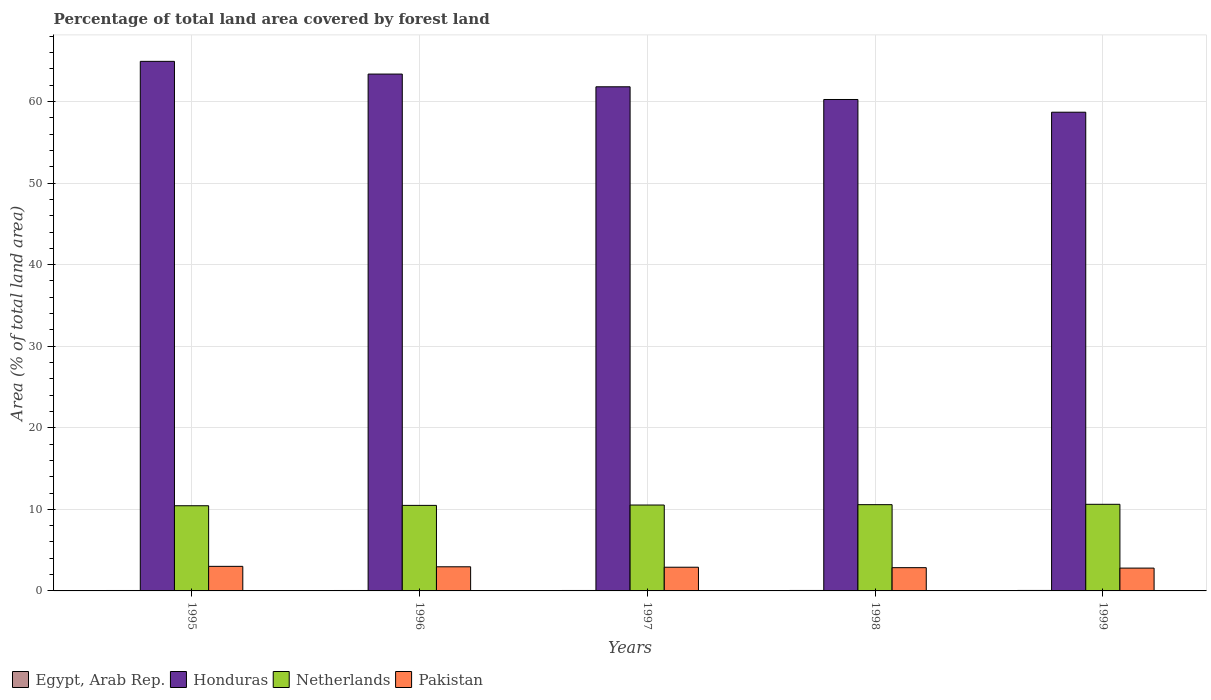How many groups of bars are there?
Offer a very short reply. 5. How many bars are there on the 4th tick from the right?
Give a very brief answer. 4. What is the percentage of forest land in Pakistan in 1997?
Give a very brief answer. 2.9. Across all years, what is the maximum percentage of forest land in Netherlands?
Offer a very short reply. 10.62. Across all years, what is the minimum percentage of forest land in Netherlands?
Make the answer very short. 10.44. What is the total percentage of forest land in Pakistan in the graph?
Ensure brevity in your answer.  14.52. What is the difference between the percentage of forest land in Pakistan in 1997 and that in 1999?
Keep it short and to the point. 0.11. What is the difference between the percentage of forest land in Pakistan in 1997 and the percentage of forest land in Honduras in 1996?
Give a very brief answer. -60.46. What is the average percentage of forest land in Egypt, Arab Rep. per year?
Keep it short and to the point. 0.05. In the year 1995, what is the difference between the percentage of forest land in Egypt, Arab Rep. and percentage of forest land in Honduras?
Offer a very short reply. -64.87. What is the ratio of the percentage of forest land in Pakistan in 1997 to that in 1999?
Offer a terse response. 1.04. Is the percentage of forest land in Pakistan in 1996 less than that in 1999?
Your response must be concise. No. Is the difference between the percentage of forest land in Egypt, Arab Rep. in 1998 and 1999 greater than the difference between the percentage of forest land in Honduras in 1998 and 1999?
Keep it short and to the point. No. What is the difference between the highest and the second highest percentage of forest land in Pakistan?
Ensure brevity in your answer.  0.05. What is the difference between the highest and the lowest percentage of forest land in Pakistan?
Your answer should be very brief. 0.21. In how many years, is the percentage of forest land in Egypt, Arab Rep. greater than the average percentage of forest land in Egypt, Arab Rep. taken over all years?
Your answer should be compact. 2. What does the 4th bar from the left in 1999 represents?
Provide a short and direct response. Pakistan. What does the 2nd bar from the right in 1998 represents?
Ensure brevity in your answer.  Netherlands. Is it the case that in every year, the sum of the percentage of forest land in Pakistan and percentage of forest land in Netherlands is greater than the percentage of forest land in Egypt, Arab Rep.?
Offer a very short reply. Yes. How many bars are there?
Offer a very short reply. 20. Are all the bars in the graph horizontal?
Your answer should be compact. No. What is the difference between two consecutive major ticks on the Y-axis?
Give a very brief answer. 10. Are the values on the major ticks of Y-axis written in scientific E-notation?
Your response must be concise. No. Does the graph contain grids?
Make the answer very short. Yes. How many legend labels are there?
Give a very brief answer. 4. How are the legend labels stacked?
Offer a very short reply. Horizontal. What is the title of the graph?
Keep it short and to the point. Percentage of total land area covered by forest land. Does "Burundi" appear as one of the legend labels in the graph?
Ensure brevity in your answer.  No. What is the label or title of the Y-axis?
Keep it short and to the point. Area (% of total land area). What is the Area (% of total land area) of Egypt, Arab Rep. in 1995?
Provide a short and direct response. 0.05. What is the Area (% of total land area) of Honduras in 1995?
Offer a very short reply. 64.92. What is the Area (% of total land area) of Netherlands in 1995?
Your response must be concise. 10.44. What is the Area (% of total land area) in Pakistan in 1995?
Keep it short and to the point. 3.01. What is the Area (% of total land area) in Egypt, Arab Rep. in 1996?
Provide a short and direct response. 0.05. What is the Area (% of total land area) in Honduras in 1996?
Your answer should be compact. 63.36. What is the Area (% of total land area) in Netherlands in 1996?
Your answer should be very brief. 10.49. What is the Area (% of total land area) in Pakistan in 1996?
Offer a very short reply. 2.96. What is the Area (% of total land area) in Egypt, Arab Rep. in 1997?
Ensure brevity in your answer.  0.05. What is the Area (% of total land area) of Honduras in 1997?
Ensure brevity in your answer.  61.8. What is the Area (% of total land area) of Netherlands in 1997?
Your response must be concise. 10.53. What is the Area (% of total land area) of Pakistan in 1997?
Offer a very short reply. 2.9. What is the Area (% of total land area) in Egypt, Arab Rep. in 1998?
Offer a terse response. 0.06. What is the Area (% of total land area) in Honduras in 1998?
Offer a terse response. 60.24. What is the Area (% of total land area) of Netherlands in 1998?
Your answer should be compact. 10.57. What is the Area (% of total land area) of Pakistan in 1998?
Your response must be concise. 2.85. What is the Area (% of total land area) of Egypt, Arab Rep. in 1999?
Ensure brevity in your answer.  0.06. What is the Area (% of total land area) in Honduras in 1999?
Provide a short and direct response. 58.69. What is the Area (% of total land area) in Netherlands in 1999?
Your answer should be compact. 10.62. What is the Area (% of total land area) in Pakistan in 1999?
Offer a very short reply. 2.8. Across all years, what is the maximum Area (% of total land area) of Egypt, Arab Rep.?
Make the answer very short. 0.06. Across all years, what is the maximum Area (% of total land area) in Honduras?
Provide a succinct answer. 64.92. Across all years, what is the maximum Area (% of total land area) in Netherlands?
Provide a succinct answer. 10.62. Across all years, what is the maximum Area (% of total land area) in Pakistan?
Your answer should be very brief. 3.01. Across all years, what is the minimum Area (% of total land area) in Egypt, Arab Rep.?
Make the answer very short. 0.05. Across all years, what is the minimum Area (% of total land area) in Honduras?
Offer a very short reply. 58.69. Across all years, what is the minimum Area (% of total land area) in Netherlands?
Offer a very short reply. 10.44. Across all years, what is the minimum Area (% of total land area) of Pakistan?
Make the answer very short. 2.8. What is the total Area (% of total land area) in Egypt, Arab Rep. in the graph?
Your response must be concise. 0.27. What is the total Area (% of total land area) in Honduras in the graph?
Provide a short and direct response. 309.02. What is the total Area (% of total land area) in Netherlands in the graph?
Your answer should be compact. 52.65. What is the total Area (% of total land area) of Pakistan in the graph?
Keep it short and to the point. 14.52. What is the difference between the Area (% of total land area) in Egypt, Arab Rep. in 1995 and that in 1996?
Offer a very short reply. -0. What is the difference between the Area (% of total land area) of Honduras in 1995 and that in 1996?
Give a very brief answer. 1.56. What is the difference between the Area (% of total land area) in Netherlands in 1995 and that in 1996?
Ensure brevity in your answer.  -0.04. What is the difference between the Area (% of total land area) of Pakistan in 1995 and that in 1996?
Your response must be concise. 0.05. What is the difference between the Area (% of total land area) of Egypt, Arab Rep. in 1995 and that in 1997?
Provide a short and direct response. -0. What is the difference between the Area (% of total land area) of Honduras in 1995 and that in 1997?
Offer a very short reply. 3.12. What is the difference between the Area (% of total land area) of Netherlands in 1995 and that in 1997?
Your answer should be very brief. -0.09. What is the difference between the Area (% of total land area) in Pakistan in 1995 and that in 1997?
Make the answer very short. 0.11. What is the difference between the Area (% of total land area) of Egypt, Arab Rep. in 1995 and that in 1998?
Your answer should be very brief. -0. What is the difference between the Area (% of total land area) of Honduras in 1995 and that in 1998?
Provide a succinct answer. 4.68. What is the difference between the Area (% of total land area) in Netherlands in 1995 and that in 1998?
Your answer should be compact. -0.13. What is the difference between the Area (% of total land area) in Pakistan in 1995 and that in 1998?
Make the answer very short. 0.16. What is the difference between the Area (% of total land area) in Egypt, Arab Rep. in 1995 and that in 1999?
Your answer should be very brief. -0.01. What is the difference between the Area (% of total land area) in Honduras in 1995 and that in 1999?
Your response must be concise. 6.23. What is the difference between the Area (% of total land area) of Netherlands in 1995 and that in 1999?
Your answer should be very brief. -0.18. What is the difference between the Area (% of total land area) of Pakistan in 1995 and that in 1999?
Provide a succinct answer. 0.21. What is the difference between the Area (% of total land area) in Egypt, Arab Rep. in 1996 and that in 1997?
Give a very brief answer. -0. What is the difference between the Area (% of total land area) of Honduras in 1996 and that in 1997?
Offer a very short reply. 1.56. What is the difference between the Area (% of total land area) in Netherlands in 1996 and that in 1997?
Your answer should be compact. -0.04. What is the difference between the Area (% of total land area) in Pakistan in 1996 and that in 1997?
Your answer should be very brief. 0.05. What is the difference between the Area (% of total land area) of Egypt, Arab Rep. in 1996 and that in 1998?
Make the answer very short. -0. What is the difference between the Area (% of total land area) of Honduras in 1996 and that in 1998?
Ensure brevity in your answer.  3.12. What is the difference between the Area (% of total land area) of Netherlands in 1996 and that in 1998?
Keep it short and to the point. -0.09. What is the difference between the Area (% of total land area) of Pakistan in 1996 and that in 1998?
Make the answer very short. 0.11. What is the difference between the Area (% of total land area) in Egypt, Arab Rep. in 1996 and that in 1999?
Provide a succinct answer. -0. What is the difference between the Area (% of total land area) of Honduras in 1996 and that in 1999?
Make the answer very short. 4.68. What is the difference between the Area (% of total land area) in Netherlands in 1996 and that in 1999?
Ensure brevity in your answer.  -0.13. What is the difference between the Area (% of total land area) in Pakistan in 1996 and that in 1999?
Provide a succinct answer. 0.16. What is the difference between the Area (% of total land area) of Egypt, Arab Rep. in 1997 and that in 1998?
Your answer should be compact. -0. What is the difference between the Area (% of total land area) in Honduras in 1997 and that in 1998?
Keep it short and to the point. 1.56. What is the difference between the Area (% of total land area) of Netherlands in 1997 and that in 1998?
Ensure brevity in your answer.  -0.04. What is the difference between the Area (% of total land area) in Pakistan in 1997 and that in 1998?
Make the answer very short. 0.05. What is the difference between the Area (% of total land area) of Egypt, Arab Rep. in 1997 and that in 1999?
Provide a succinct answer. -0. What is the difference between the Area (% of total land area) of Honduras in 1997 and that in 1999?
Your answer should be very brief. 3.12. What is the difference between the Area (% of total land area) of Netherlands in 1997 and that in 1999?
Your answer should be compact. -0.09. What is the difference between the Area (% of total land area) in Pakistan in 1997 and that in 1999?
Give a very brief answer. 0.11. What is the difference between the Area (% of total land area) of Egypt, Arab Rep. in 1998 and that in 1999?
Give a very brief answer. -0. What is the difference between the Area (% of total land area) of Honduras in 1998 and that in 1999?
Your response must be concise. 1.56. What is the difference between the Area (% of total land area) of Netherlands in 1998 and that in 1999?
Keep it short and to the point. -0.04. What is the difference between the Area (% of total land area) of Pakistan in 1998 and that in 1999?
Offer a terse response. 0.05. What is the difference between the Area (% of total land area) in Egypt, Arab Rep. in 1995 and the Area (% of total land area) in Honduras in 1996?
Provide a succinct answer. -63.31. What is the difference between the Area (% of total land area) in Egypt, Arab Rep. in 1995 and the Area (% of total land area) in Netherlands in 1996?
Provide a succinct answer. -10.43. What is the difference between the Area (% of total land area) of Egypt, Arab Rep. in 1995 and the Area (% of total land area) of Pakistan in 1996?
Your answer should be compact. -2.91. What is the difference between the Area (% of total land area) in Honduras in 1995 and the Area (% of total land area) in Netherlands in 1996?
Your answer should be compact. 54.44. What is the difference between the Area (% of total land area) of Honduras in 1995 and the Area (% of total land area) of Pakistan in 1996?
Offer a terse response. 61.96. What is the difference between the Area (% of total land area) in Netherlands in 1995 and the Area (% of total land area) in Pakistan in 1996?
Your response must be concise. 7.48. What is the difference between the Area (% of total land area) of Egypt, Arab Rep. in 1995 and the Area (% of total land area) of Honduras in 1997?
Keep it short and to the point. -61.75. What is the difference between the Area (% of total land area) in Egypt, Arab Rep. in 1995 and the Area (% of total land area) in Netherlands in 1997?
Keep it short and to the point. -10.48. What is the difference between the Area (% of total land area) of Egypt, Arab Rep. in 1995 and the Area (% of total land area) of Pakistan in 1997?
Provide a short and direct response. -2.85. What is the difference between the Area (% of total land area) of Honduras in 1995 and the Area (% of total land area) of Netherlands in 1997?
Offer a very short reply. 54.39. What is the difference between the Area (% of total land area) of Honduras in 1995 and the Area (% of total land area) of Pakistan in 1997?
Your answer should be very brief. 62.02. What is the difference between the Area (% of total land area) of Netherlands in 1995 and the Area (% of total land area) of Pakistan in 1997?
Your answer should be very brief. 7.54. What is the difference between the Area (% of total land area) in Egypt, Arab Rep. in 1995 and the Area (% of total land area) in Honduras in 1998?
Ensure brevity in your answer.  -60.19. What is the difference between the Area (% of total land area) of Egypt, Arab Rep. in 1995 and the Area (% of total land area) of Netherlands in 1998?
Provide a short and direct response. -10.52. What is the difference between the Area (% of total land area) in Egypt, Arab Rep. in 1995 and the Area (% of total land area) in Pakistan in 1998?
Keep it short and to the point. -2.8. What is the difference between the Area (% of total land area) of Honduras in 1995 and the Area (% of total land area) of Netherlands in 1998?
Provide a succinct answer. 54.35. What is the difference between the Area (% of total land area) in Honduras in 1995 and the Area (% of total land area) in Pakistan in 1998?
Give a very brief answer. 62.07. What is the difference between the Area (% of total land area) in Netherlands in 1995 and the Area (% of total land area) in Pakistan in 1998?
Provide a succinct answer. 7.59. What is the difference between the Area (% of total land area) of Egypt, Arab Rep. in 1995 and the Area (% of total land area) of Honduras in 1999?
Your answer should be very brief. -58.63. What is the difference between the Area (% of total land area) of Egypt, Arab Rep. in 1995 and the Area (% of total land area) of Netherlands in 1999?
Your answer should be compact. -10.57. What is the difference between the Area (% of total land area) of Egypt, Arab Rep. in 1995 and the Area (% of total land area) of Pakistan in 1999?
Provide a succinct answer. -2.75. What is the difference between the Area (% of total land area) in Honduras in 1995 and the Area (% of total land area) in Netherlands in 1999?
Ensure brevity in your answer.  54.3. What is the difference between the Area (% of total land area) of Honduras in 1995 and the Area (% of total land area) of Pakistan in 1999?
Offer a very short reply. 62.12. What is the difference between the Area (% of total land area) in Netherlands in 1995 and the Area (% of total land area) in Pakistan in 1999?
Your answer should be compact. 7.64. What is the difference between the Area (% of total land area) in Egypt, Arab Rep. in 1996 and the Area (% of total land area) in Honduras in 1997?
Your response must be concise. -61.75. What is the difference between the Area (% of total land area) in Egypt, Arab Rep. in 1996 and the Area (% of total land area) in Netherlands in 1997?
Your answer should be compact. -10.48. What is the difference between the Area (% of total land area) in Egypt, Arab Rep. in 1996 and the Area (% of total land area) in Pakistan in 1997?
Your answer should be very brief. -2.85. What is the difference between the Area (% of total land area) of Honduras in 1996 and the Area (% of total land area) of Netherlands in 1997?
Your answer should be compact. 52.83. What is the difference between the Area (% of total land area) of Honduras in 1996 and the Area (% of total land area) of Pakistan in 1997?
Your answer should be very brief. 60.46. What is the difference between the Area (% of total land area) in Netherlands in 1996 and the Area (% of total land area) in Pakistan in 1997?
Keep it short and to the point. 7.58. What is the difference between the Area (% of total land area) in Egypt, Arab Rep. in 1996 and the Area (% of total land area) in Honduras in 1998?
Provide a succinct answer. -60.19. What is the difference between the Area (% of total land area) in Egypt, Arab Rep. in 1996 and the Area (% of total land area) in Netherlands in 1998?
Provide a succinct answer. -10.52. What is the difference between the Area (% of total land area) of Egypt, Arab Rep. in 1996 and the Area (% of total land area) of Pakistan in 1998?
Provide a short and direct response. -2.8. What is the difference between the Area (% of total land area) of Honduras in 1996 and the Area (% of total land area) of Netherlands in 1998?
Keep it short and to the point. 52.79. What is the difference between the Area (% of total land area) of Honduras in 1996 and the Area (% of total land area) of Pakistan in 1998?
Ensure brevity in your answer.  60.51. What is the difference between the Area (% of total land area) in Netherlands in 1996 and the Area (% of total land area) in Pakistan in 1998?
Your answer should be compact. 7.63. What is the difference between the Area (% of total land area) of Egypt, Arab Rep. in 1996 and the Area (% of total land area) of Honduras in 1999?
Provide a succinct answer. -58.63. What is the difference between the Area (% of total land area) in Egypt, Arab Rep. in 1996 and the Area (% of total land area) in Netherlands in 1999?
Provide a short and direct response. -10.57. What is the difference between the Area (% of total land area) of Egypt, Arab Rep. in 1996 and the Area (% of total land area) of Pakistan in 1999?
Offer a terse response. -2.75. What is the difference between the Area (% of total land area) in Honduras in 1996 and the Area (% of total land area) in Netherlands in 1999?
Provide a succinct answer. 52.74. What is the difference between the Area (% of total land area) in Honduras in 1996 and the Area (% of total land area) in Pakistan in 1999?
Provide a short and direct response. 60.56. What is the difference between the Area (% of total land area) in Netherlands in 1996 and the Area (% of total land area) in Pakistan in 1999?
Your answer should be compact. 7.69. What is the difference between the Area (% of total land area) in Egypt, Arab Rep. in 1997 and the Area (% of total land area) in Honduras in 1998?
Your response must be concise. -60.19. What is the difference between the Area (% of total land area) in Egypt, Arab Rep. in 1997 and the Area (% of total land area) in Netherlands in 1998?
Offer a very short reply. -10.52. What is the difference between the Area (% of total land area) in Egypt, Arab Rep. in 1997 and the Area (% of total land area) in Pakistan in 1998?
Give a very brief answer. -2.8. What is the difference between the Area (% of total land area) in Honduras in 1997 and the Area (% of total land area) in Netherlands in 1998?
Keep it short and to the point. 51.23. What is the difference between the Area (% of total land area) in Honduras in 1997 and the Area (% of total land area) in Pakistan in 1998?
Offer a very short reply. 58.95. What is the difference between the Area (% of total land area) of Netherlands in 1997 and the Area (% of total land area) of Pakistan in 1998?
Your response must be concise. 7.68. What is the difference between the Area (% of total land area) in Egypt, Arab Rep. in 1997 and the Area (% of total land area) in Honduras in 1999?
Give a very brief answer. -58.63. What is the difference between the Area (% of total land area) of Egypt, Arab Rep. in 1997 and the Area (% of total land area) of Netherlands in 1999?
Ensure brevity in your answer.  -10.56. What is the difference between the Area (% of total land area) of Egypt, Arab Rep. in 1997 and the Area (% of total land area) of Pakistan in 1999?
Ensure brevity in your answer.  -2.74. What is the difference between the Area (% of total land area) in Honduras in 1997 and the Area (% of total land area) in Netherlands in 1999?
Give a very brief answer. 51.18. What is the difference between the Area (% of total land area) in Honduras in 1997 and the Area (% of total land area) in Pakistan in 1999?
Your response must be concise. 59.01. What is the difference between the Area (% of total land area) of Netherlands in 1997 and the Area (% of total land area) of Pakistan in 1999?
Make the answer very short. 7.73. What is the difference between the Area (% of total land area) in Egypt, Arab Rep. in 1998 and the Area (% of total land area) in Honduras in 1999?
Your answer should be very brief. -58.63. What is the difference between the Area (% of total land area) of Egypt, Arab Rep. in 1998 and the Area (% of total land area) of Netherlands in 1999?
Make the answer very short. -10.56. What is the difference between the Area (% of total land area) in Egypt, Arab Rep. in 1998 and the Area (% of total land area) in Pakistan in 1999?
Make the answer very short. -2.74. What is the difference between the Area (% of total land area) of Honduras in 1998 and the Area (% of total land area) of Netherlands in 1999?
Give a very brief answer. 49.63. What is the difference between the Area (% of total land area) of Honduras in 1998 and the Area (% of total land area) of Pakistan in 1999?
Your answer should be compact. 57.45. What is the difference between the Area (% of total land area) of Netherlands in 1998 and the Area (% of total land area) of Pakistan in 1999?
Keep it short and to the point. 7.78. What is the average Area (% of total land area) of Egypt, Arab Rep. per year?
Provide a short and direct response. 0.05. What is the average Area (% of total land area) of Honduras per year?
Keep it short and to the point. 61.8. What is the average Area (% of total land area) in Netherlands per year?
Your response must be concise. 10.53. What is the average Area (% of total land area) in Pakistan per year?
Ensure brevity in your answer.  2.9. In the year 1995, what is the difference between the Area (% of total land area) of Egypt, Arab Rep. and Area (% of total land area) of Honduras?
Ensure brevity in your answer.  -64.87. In the year 1995, what is the difference between the Area (% of total land area) in Egypt, Arab Rep. and Area (% of total land area) in Netherlands?
Provide a succinct answer. -10.39. In the year 1995, what is the difference between the Area (% of total land area) in Egypt, Arab Rep. and Area (% of total land area) in Pakistan?
Keep it short and to the point. -2.96. In the year 1995, what is the difference between the Area (% of total land area) in Honduras and Area (% of total land area) in Netherlands?
Offer a very short reply. 54.48. In the year 1995, what is the difference between the Area (% of total land area) of Honduras and Area (% of total land area) of Pakistan?
Offer a very short reply. 61.91. In the year 1995, what is the difference between the Area (% of total land area) in Netherlands and Area (% of total land area) in Pakistan?
Your answer should be compact. 7.43. In the year 1996, what is the difference between the Area (% of total land area) of Egypt, Arab Rep. and Area (% of total land area) of Honduras?
Provide a short and direct response. -63.31. In the year 1996, what is the difference between the Area (% of total land area) of Egypt, Arab Rep. and Area (% of total land area) of Netherlands?
Your answer should be very brief. -10.43. In the year 1996, what is the difference between the Area (% of total land area) of Egypt, Arab Rep. and Area (% of total land area) of Pakistan?
Offer a very short reply. -2.9. In the year 1996, what is the difference between the Area (% of total land area) in Honduras and Area (% of total land area) in Netherlands?
Provide a short and direct response. 52.88. In the year 1996, what is the difference between the Area (% of total land area) in Honduras and Area (% of total land area) in Pakistan?
Make the answer very short. 60.4. In the year 1996, what is the difference between the Area (% of total land area) of Netherlands and Area (% of total land area) of Pakistan?
Offer a very short reply. 7.53. In the year 1997, what is the difference between the Area (% of total land area) in Egypt, Arab Rep. and Area (% of total land area) in Honduras?
Provide a short and direct response. -61.75. In the year 1997, what is the difference between the Area (% of total land area) in Egypt, Arab Rep. and Area (% of total land area) in Netherlands?
Provide a succinct answer. -10.48. In the year 1997, what is the difference between the Area (% of total land area) in Egypt, Arab Rep. and Area (% of total land area) in Pakistan?
Your response must be concise. -2.85. In the year 1997, what is the difference between the Area (% of total land area) of Honduras and Area (% of total land area) of Netherlands?
Make the answer very short. 51.27. In the year 1997, what is the difference between the Area (% of total land area) in Honduras and Area (% of total land area) in Pakistan?
Ensure brevity in your answer.  58.9. In the year 1997, what is the difference between the Area (% of total land area) of Netherlands and Area (% of total land area) of Pakistan?
Offer a very short reply. 7.63. In the year 1998, what is the difference between the Area (% of total land area) in Egypt, Arab Rep. and Area (% of total land area) in Honduras?
Make the answer very short. -60.19. In the year 1998, what is the difference between the Area (% of total land area) in Egypt, Arab Rep. and Area (% of total land area) in Netherlands?
Your answer should be very brief. -10.52. In the year 1998, what is the difference between the Area (% of total land area) in Egypt, Arab Rep. and Area (% of total land area) in Pakistan?
Offer a very short reply. -2.8. In the year 1998, what is the difference between the Area (% of total land area) of Honduras and Area (% of total land area) of Netherlands?
Provide a succinct answer. 49.67. In the year 1998, what is the difference between the Area (% of total land area) in Honduras and Area (% of total land area) in Pakistan?
Your answer should be compact. 57.39. In the year 1998, what is the difference between the Area (% of total land area) of Netherlands and Area (% of total land area) of Pakistan?
Your answer should be compact. 7.72. In the year 1999, what is the difference between the Area (% of total land area) in Egypt, Arab Rep. and Area (% of total land area) in Honduras?
Ensure brevity in your answer.  -58.63. In the year 1999, what is the difference between the Area (% of total land area) in Egypt, Arab Rep. and Area (% of total land area) in Netherlands?
Ensure brevity in your answer.  -10.56. In the year 1999, what is the difference between the Area (% of total land area) in Egypt, Arab Rep. and Area (% of total land area) in Pakistan?
Offer a terse response. -2.74. In the year 1999, what is the difference between the Area (% of total land area) in Honduras and Area (% of total land area) in Netherlands?
Offer a terse response. 48.07. In the year 1999, what is the difference between the Area (% of total land area) in Honduras and Area (% of total land area) in Pakistan?
Provide a succinct answer. 55.89. In the year 1999, what is the difference between the Area (% of total land area) in Netherlands and Area (% of total land area) in Pakistan?
Offer a terse response. 7.82. What is the ratio of the Area (% of total land area) in Egypt, Arab Rep. in 1995 to that in 1996?
Provide a succinct answer. 0.97. What is the ratio of the Area (% of total land area) in Honduras in 1995 to that in 1996?
Provide a short and direct response. 1.02. What is the ratio of the Area (% of total land area) in Pakistan in 1995 to that in 1996?
Offer a very short reply. 1.02. What is the ratio of the Area (% of total land area) of Egypt, Arab Rep. in 1995 to that in 1997?
Provide a short and direct response. 0.94. What is the ratio of the Area (% of total land area) in Honduras in 1995 to that in 1997?
Ensure brevity in your answer.  1.05. What is the ratio of the Area (% of total land area) in Netherlands in 1995 to that in 1997?
Offer a very short reply. 0.99. What is the ratio of the Area (% of total land area) in Pakistan in 1995 to that in 1997?
Offer a terse response. 1.04. What is the ratio of the Area (% of total land area) of Egypt, Arab Rep. in 1995 to that in 1998?
Offer a terse response. 0.92. What is the ratio of the Area (% of total land area) of Honduras in 1995 to that in 1998?
Offer a terse response. 1.08. What is the ratio of the Area (% of total land area) in Netherlands in 1995 to that in 1998?
Offer a terse response. 0.99. What is the ratio of the Area (% of total land area) in Pakistan in 1995 to that in 1998?
Give a very brief answer. 1.06. What is the ratio of the Area (% of total land area) of Egypt, Arab Rep. in 1995 to that in 1999?
Keep it short and to the point. 0.9. What is the ratio of the Area (% of total land area) in Honduras in 1995 to that in 1999?
Provide a short and direct response. 1.11. What is the ratio of the Area (% of total land area) in Netherlands in 1995 to that in 1999?
Give a very brief answer. 0.98. What is the ratio of the Area (% of total land area) in Pakistan in 1995 to that in 1999?
Keep it short and to the point. 1.08. What is the ratio of the Area (% of total land area) in Egypt, Arab Rep. in 1996 to that in 1997?
Keep it short and to the point. 0.97. What is the ratio of the Area (% of total land area) of Honduras in 1996 to that in 1997?
Make the answer very short. 1.03. What is the ratio of the Area (% of total land area) in Pakistan in 1996 to that in 1997?
Your answer should be compact. 1.02. What is the ratio of the Area (% of total land area) of Egypt, Arab Rep. in 1996 to that in 1998?
Provide a short and direct response. 0.95. What is the ratio of the Area (% of total land area) of Honduras in 1996 to that in 1998?
Provide a short and direct response. 1.05. What is the ratio of the Area (% of total land area) in Netherlands in 1996 to that in 1998?
Your answer should be very brief. 0.99. What is the ratio of the Area (% of total land area) in Pakistan in 1996 to that in 1998?
Ensure brevity in your answer.  1.04. What is the ratio of the Area (% of total land area) in Egypt, Arab Rep. in 1996 to that in 1999?
Provide a succinct answer. 0.92. What is the ratio of the Area (% of total land area) of Honduras in 1996 to that in 1999?
Offer a very short reply. 1.08. What is the ratio of the Area (% of total land area) in Netherlands in 1996 to that in 1999?
Provide a succinct answer. 0.99. What is the ratio of the Area (% of total land area) in Pakistan in 1996 to that in 1999?
Ensure brevity in your answer.  1.06. What is the ratio of the Area (% of total land area) of Egypt, Arab Rep. in 1997 to that in 1998?
Ensure brevity in your answer.  0.97. What is the ratio of the Area (% of total land area) of Honduras in 1997 to that in 1998?
Give a very brief answer. 1.03. What is the ratio of the Area (% of total land area) in Netherlands in 1997 to that in 1998?
Offer a terse response. 1. What is the ratio of the Area (% of total land area) of Pakistan in 1997 to that in 1998?
Ensure brevity in your answer.  1.02. What is the ratio of the Area (% of total land area) of Egypt, Arab Rep. in 1997 to that in 1999?
Keep it short and to the point. 0.95. What is the ratio of the Area (% of total land area) in Honduras in 1997 to that in 1999?
Make the answer very short. 1.05. What is the ratio of the Area (% of total land area) in Netherlands in 1997 to that in 1999?
Provide a succinct answer. 0.99. What is the ratio of the Area (% of total land area) of Pakistan in 1997 to that in 1999?
Offer a terse response. 1.04. What is the ratio of the Area (% of total land area) in Egypt, Arab Rep. in 1998 to that in 1999?
Offer a very short reply. 0.97. What is the ratio of the Area (% of total land area) of Honduras in 1998 to that in 1999?
Give a very brief answer. 1.03. What is the ratio of the Area (% of total land area) of Netherlands in 1998 to that in 1999?
Your answer should be very brief. 1. What is the ratio of the Area (% of total land area) in Pakistan in 1998 to that in 1999?
Keep it short and to the point. 1.02. What is the difference between the highest and the second highest Area (% of total land area) of Egypt, Arab Rep.?
Make the answer very short. 0. What is the difference between the highest and the second highest Area (% of total land area) of Honduras?
Your answer should be compact. 1.56. What is the difference between the highest and the second highest Area (% of total land area) in Netherlands?
Offer a terse response. 0.04. What is the difference between the highest and the second highest Area (% of total land area) in Pakistan?
Offer a terse response. 0.05. What is the difference between the highest and the lowest Area (% of total land area) in Egypt, Arab Rep.?
Provide a short and direct response. 0.01. What is the difference between the highest and the lowest Area (% of total land area) of Honduras?
Give a very brief answer. 6.23. What is the difference between the highest and the lowest Area (% of total land area) of Netherlands?
Make the answer very short. 0.18. What is the difference between the highest and the lowest Area (% of total land area) in Pakistan?
Your response must be concise. 0.21. 